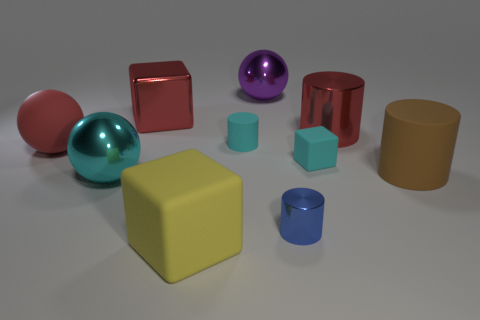What number of things are either large things to the left of the large rubber block or metal spheres that are in front of the large brown matte object?
Offer a very short reply. 3. Are there fewer small purple spheres than yellow matte objects?
Your response must be concise. Yes. How many things are either tiny rubber blocks or large things?
Keep it short and to the point. 8. Is the big cyan thing the same shape as the big red rubber object?
Offer a terse response. Yes. There is a ball that is behind the rubber ball; is its size the same as the cube to the right of the big matte block?
Offer a terse response. No. The cylinder that is both in front of the cyan block and behind the tiny blue cylinder is made of what material?
Offer a terse response. Rubber. Is there anything else that has the same color as the big matte cube?
Ensure brevity in your answer.  No. Are there fewer yellow objects that are in front of the big rubber cube than cubes?
Your answer should be very brief. Yes. Are there more blue metal cylinders than small brown metal cylinders?
Offer a terse response. Yes. Are there any cylinders in front of the metallic cylinder that is behind the red object that is in front of the red cylinder?
Make the answer very short. Yes. 